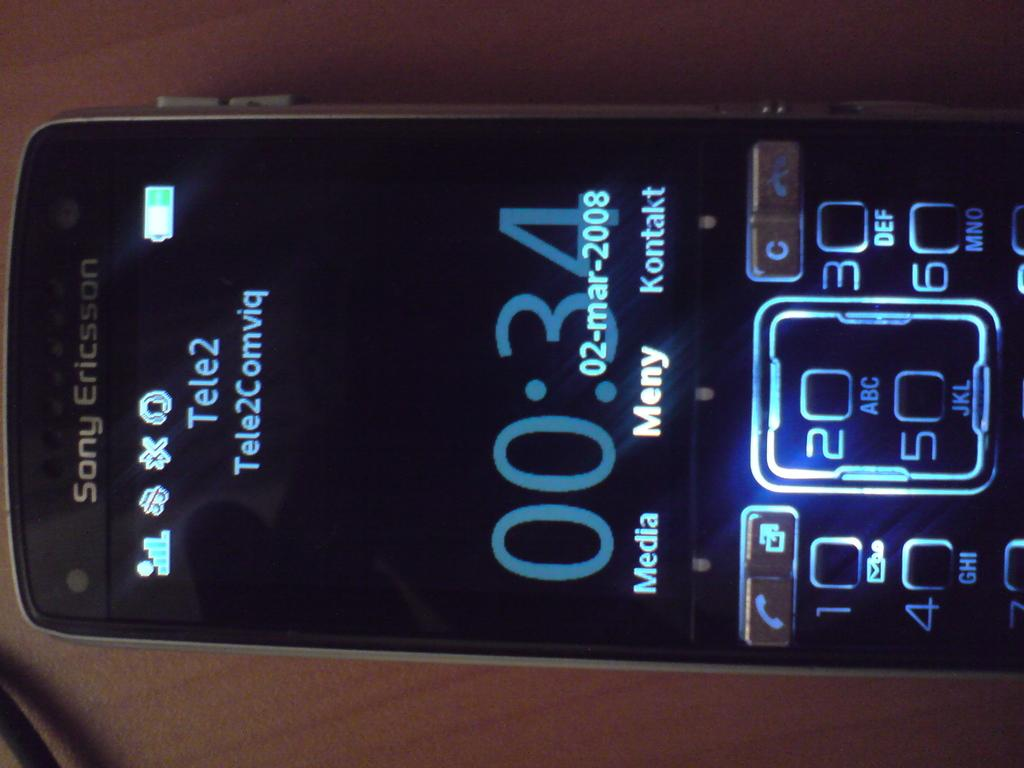Provide a one-sentence caption for the provided image. Sony Ericsson shows a 34 second call on this phone. 